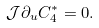Convert formula to latex. <formula><loc_0><loc_0><loc_500><loc_500>\mathcal { J } \partial _ { u } C _ { 4 } ^ { * } = 0 .</formula> 